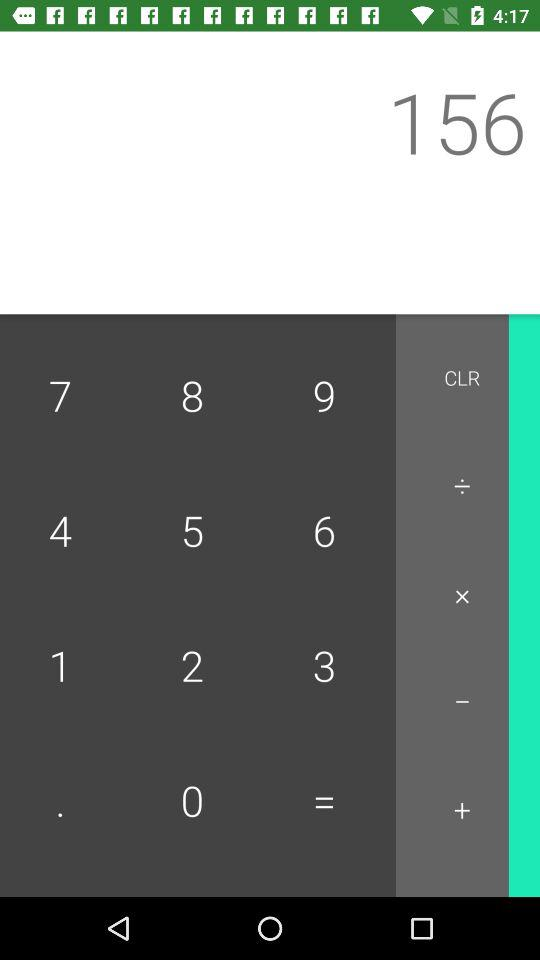What is the name of the application?
When the provided information is insufficient, respond with <no answer>. <no answer> 